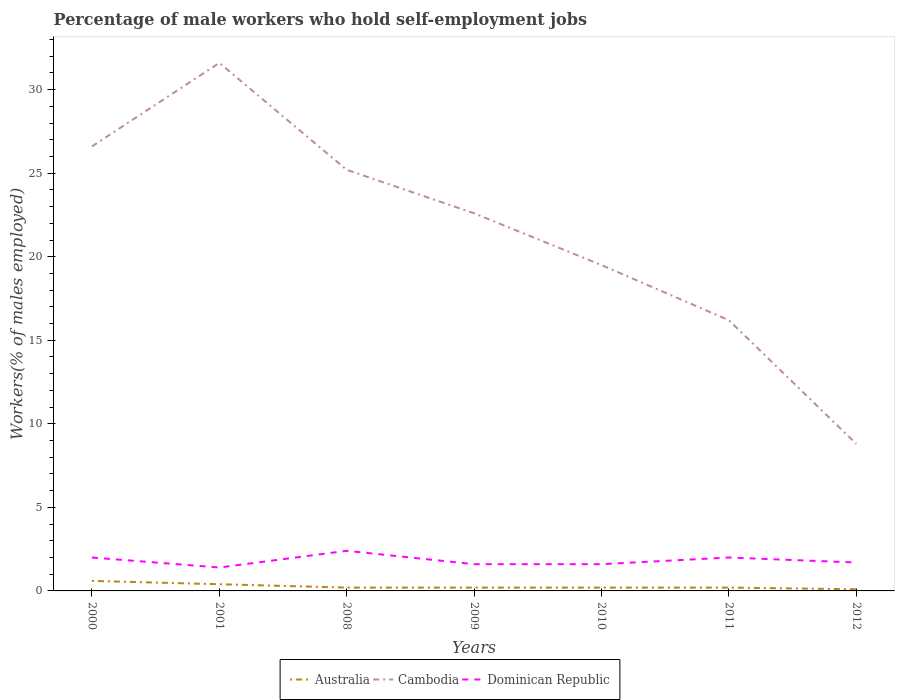Is the number of lines equal to the number of legend labels?
Keep it short and to the point. Yes. Across all years, what is the maximum percentage of self-employed male workers in Australia?
Ensure brevity in your answer.  0.1. What is the total percentage of self-employed male workers in Australia in the graph?
Keep it short and to the point. 0.1. What is the difference between the highest and the second highest percentage of self-employed male workers in Dominican Republic?
Make the answer very short. 1. What is the difference between the highest and the lowest percentage of self-employed male workers in Dominican Republic?
Provide a succinct answer. 3. How many lines are there?
Keep it short and to the point. 3. What is the difference between two consecutive major ticks on the Y-axis?
Your answer should be very brief. 5. Does the graph contain any zero values?
Offer a very short reply. No. What is the title of the graph?
Provide a succinct answer. Percentage of male workers who hold self-employment jobs. Does "Isle of Man" appear as one of the legend labels in the graph?
Your response must be concise. No. What is the label or title of the X-axis?
Provide a succinct answer. Years. What is the label or title of the Y-axis?
Make the answer very short. Workers(% of males employed). What is the Workers(% of males employed) in Australia in 2000?
Make the answer very short. 0.6. What is the Workers(% of males employed) in Cambodia in 2000?
Your answer should be compact. 26.6. What is the Workers(% of males employed) in Dominican Republic in 2000?
Keep it short and to the point. 2. What is the Workers(% of males employed) of Australia in 2001?
Your answer should be very brief. 0.4. What is the Workers(% of males employed) in Cambodia in 2001?
Offer a terse response. 31.6. What is the Workers(% of males employed) in Dominican Republic in 2001?
Offer a very short reply. 1.4. What is the Workers(% of males employed) in Australia in 2008?
Provide a succinct answer. 0.2. What is the Workers(% of males employed) in Cambodia in 2008?
Give a very brief answer. 25.2. What is the Workers(% of males employed) in Dominican Republic in 2008?
Offer a very short reply. 2.4. What is the Workers(% of males employed) of Australia in 2009?
Provide a succinct answer. 0.2. What is the Workers(% of males employed) in Cambodia in 2009?
Keep it short and to the point. 22.6. What is the Workers(% of males employed) of Dominican Republic in 2009?
Ensure brevity in your answer.  1.6. What is the Workers(% of males employed) of Australia in 2010?
Ensure brevity in your answer.  0.2. What is the Workers(% of males employed) of Cambodia in 2010?
Offer a terse response. 19.5. What is the Workers(% of males employed) in Dominican Republic in 2010?
Your answer should be very brief. 1.6. What is the Workers(% of males employed) of Australia in 2011?
Offer a terse response. 0.2. What is the Workers(% of males employed) in Cambodia in 2011?
Your response must be concise. 16.2. What is the Workers(% of males employed) of Australia in 2012?
Keep it short and to the point. 0.1. What is the Workers(% of males employed) in Cambodia in 2012?
Your response must be concise. 8.8. What is the Workers(% of males employed) of Dominican Republic in 2012?
Provide a succinct answer. 1.7. Across all years, what is the maximum Workers(% of males employed) of Australia?
Keep it short and to the point. 0.6. Across all years, what is the maximum Workers(% of males employed) of Cambodia?
Your answer should be compact. 31.6. Across all years, what is the maximum Workers(% of males employed) of Dominican Republic?
Provide a short and direct response. 2.4. Across all years, what is the minimum Workers(% of males employed) of Australia?
Make the answer very short. 0.1. Across all years, what is the minimum Workers(% of males employed) in Cambodia?
Your response must be concise. 8.8. Across all years, what is the minimum Workers(% of males employed) of Dominican Republic?
Provide a short and direct response. 1.4. What is the total Workers(% of males employed) in Cambodia in the graph?
Give a very brief answer. 150.5. What is the difference between the Workers(% of males employed) of Australia in 2000 and that in 2001?
Keep it short and to the point. 0.2. What is the difference between the Workers(% of males employed) in Cambodia in 2000 and that in 2001?
Provide a short and direct response. -5. What is the difference between the Workers(% of males employed) of Dominican Republic in 2000 and that in 2001?
Your response must be concise. 0.6. What is the difference between the Workers(% of males employed) of Cambodia in 2000 and that in 2009?
Offer a very short reply. 4. What is the difference between the Workers(% of males employed) in Australia in 2000 and that in 2011?
Keep it short and to the point. 0.4. What is the difference between the Workers(% of males employed) of Cambodia in 2000 and that in 2011?
Provide a succinct answer. 10.4. What is the difference between the Workers(% of males employed) of Australia in 2000 and that in 2012?
Your answer should be very brief. 0.5. What is the difference between the Workers(% of males employed) of Dominican Republic in 2000 and that in 2012?
Offer a terse response. 0.3. What is the difference between the Workers(% of males employed) of Australia in 2001 and that in 2008?
Offer a very short reply. 0.2. What is the difference between the Workers(% of males employed) in Dominican Republic in 2001 and that in 2008?
Give a very brief answer. -1. What is the difference between the Workers(% of males employed) of Australia in 2001 and that in 2009?
Provide a succinct answer. 0.2. What is the difference between the Workers(% of males employed) of Australia in 2001 and that in 2010?
Give a very brief answer. 0.2. What is the difference between the Workers(% of males employed) in Dominican Republic in 2001 and that in 2010?
Give a very brief answer. -0.2. What is the difference between the Workers(% of males employed) in Australia in 2001 and that in 2011?
Your answer should be very brief. 0.2. What is the difference between the Workers(% of males employed) of Cambodia in 2001 and that in 2011?
Your response must be concise. 15.4. What is the difference between the Workers(% of males employed) in Dominican Republic in 2001 and that in 2011?
Your response must be concise. -0.6. What is the difference between the Workers(% of males employed) of Cambodia in 2001 and that in 2012?
Offer a very short reply. 22.8. What is the difference between the Workers(% of males employed) of Cambodia in 2008 and that in 2009?
Keep it short and to the point. 2.6. What is the difference between the Workers(% of males employed) of Dominican Republic in 2008 and that in 2009?
Give a very brief answer. 0.8. What is the difference between the Workers(% of males employed) of Cambodia in 2008 and that in 2010?
Ensure brevity in your answer.  5.7. What is the difference between the Workers(% of males employed) in Dominican Republic in 2008 and that in 2010?
Your response must be concise. 0.8. What is the difference between the Workers(% of males employed) in Australia in 2008 and that in 2011?
Your answer should be very brief. 0. What is the difference between the Workers(% of males employed) in Dominican Republic in 2008 and that in 2011?
Offer a very short reply. 0.4. What is the difference between the Workers(% of males employed) of Dominican Republic in 2008 and that in 2012?
Provide a short and direct response. 0.7. What is the difference between the Workers(% of males employed) of Cambodia in 2009 and that in 2010?
Your answer should be compact. 3.1. What is the difference between the Workers(% of males employed) in Dominican Republic in 2009 and that in 2011?
Offer a very short reply. -0.4. What is the difference between the Workers(% of males employed) in Australia in 2009 and that in 2012?
Ensure brevity in your answer.  0.1. What is the difference between the Workers(% of males employed) in Cambodia in 2009 and that in 2012?
Provide a succinct answer. 13.8. What is the difference between the Workers(% of males employed) in Dominican Republic in 2009 and that in 2012?
Your answer should be compact. -0.1. What is the difference between the Workers(% of males employed) in Australia in 2010 and that in 2011?
Give a very brief answer. 0. What is the difference between the Workers(% of males employed) in Cambodia in 2010 and that in 2011?
Ensure brevity in your answer.  3.3. What is the difference between the Workers(% of males employed) of Dominican Republic in 2010 and that in 2011?
Offer a very short reply. -0.4. What is the difference between the Workers(% of males employed) in Cambodia in 2011 and that in 2012?
Ensure brevity in your answer.  7.4. What is the difference between the Workers(% of males employed) in Australia in 2000 and the Workers(% of males employed) in Cambodia in 2001?
Your response must be concise. -31. What is the difference between the Workers(% of males employed) in Cambodia in 2000 and the Workers(% of males employed) in Dominican Republic in 2001?
Offer a terse response. 25.2. What is the difference between the Workers(% of males employed) in Australia in 2000 and the Workers(% of males employed) in Cambodia in 2008?
Offer a terse response. -24.6. What is the difference between the Workers(% of males employed) of Australia in 2000 and the Workers(% of males employed) of Dominican Republic in 2008?
Give a very brief answer. -1.8. What is the difference between the Workers(% of males employed) of Cambodia in 2000 and the Workers(% of males employed) of Dominican Republic in 2008?
Ensure brevity in your answer.  24.2. What is the difference between the Workers(% of males employed) in Australia in 2000 and the Workers(% of males employed) in Cambodia in 2009?
Provide a short and direct response. -22. What is the difference between the Workers(% of males employed) in Australia in 2000 and the Workers(% of males employed) in Dominican Republic in 2009?
Ensure brevity in your answer.  -1. What is the difference between the Workers(% of males employed) in Australia in 2000 and the Workers(% of males employed) in Cambodia in 2010?
Ensure brevity in your answer.  -18.9. What is the difference between the Workers(% of males employed) of Australia in 2000 and the Workers(% of males employed) of Dominican Republic in 2010?
Your answer should be compact. -1. What is the difference between the Workers(% of males employed) of Australia in 2000 and the Workers(% of males employed) of Cambodia in 2011?
Make the answer very short. -15.6. What is the difference between the Workers(% of males employed) in Australia in 2000 and the Workers(% of males employed) in Dominican Republic in 2011?
Your answer should be very brief. -1.4. What is the difference between the Workers(% of males employed) of Cambodia in 2000 and the Workers(% of males employed) of Dominican Republic in 2011?
Give a very brief answer. 24.6. What is the difference between the Workers(% of males employed) of Cambodia in 2000 and the Workers(% of males employed) of Dominican Republic in 2012?
Ensure brevity in your answer.  24.9. What is the difference between the Workers(% of males employed) in Australia in 2001 and the Workers(% of males employed) in Cambodia in 2008?
Your answer should be compact. -24.8. What is the difference between the Workers(% of males employed) of Cambodia in 2001 and the Workers(% of males employed) of Dominican Republic in 2008?
Your answer should be compact. 29.2. What is the difference between the Workers(% of males employed) of Australia in 2001 and the Workers(% of males employed) of Cambodia in 2009?
Offer a very short reply. -22.2. What is the difference between the Workers(% of males employed) of Australia in 2001 and the Workers(% of males employed) of Dominican Republic in 2009?
Keep it short and to the point. -1.2. What is the difference between the Workers(% of males employed) in Australia in 2001 and the Workers(% of males employed) in Cambodia in 2010?
Your response must be concise. -19.1. What is the difference between the Workers(% of males employed) of Australia in 2001 and the Workers(% of males employed) of Cambodia in 2011?
Keep it short and to the point. -15.8. What is the difference between the Workers(% of males employed) of Cambodia in 2001 and the Workers(% of males employed) of Dominican Republic in 2011?
Provide a succinct answer. 29.6. What is the difference between the Workers(% of males employed) of Australia in 2001 and the Workers(% of males employed) of Dominican Republic in 2012?
Your response must be concise. -1.3. What is the difference between the Workers(% of males employed) in Cambodia in 2001 and the Workers(% of males employed) in Dominican Republic in 2012?
Your answer should be very brief. 29.9. What is the difference between the Workers(% of males employed) of Australia in 2008 and the Workers(% of males employed) of Cambodia in 2009?
Keep it short and to the point. -22.4. What is the difference between the Workers(% of males employed) of Cambodia in 2008 and the Workers(% of males employed) of Dominican Republic in 2009?
Give a very brief answer. 23.6. What is the difference between the Workers(% of males employed) in Australia in 2008 and the Workers(% of males employed) in Cambodia in 2010?
Offer a terse response. -19.3. What is the difference between the Workers(% of males employed) in Cambodia in 2008 and the Workers(% of males employed) in Dominican Republic in 2010?
Your answer should be very brief. 23.6. What is the difference between the Workers(% of males employed) in Australia in 2008 and the Workers(% of males employed) in Cambodia in 2011?
Your answer should be compact. -16. What is the difference between the Workers(% of males employed) in Cambodia in 2008 and the Workers(% of males employed) in Dominican Republic in 2011?
Ensure brevity in your answer.  23.2. What is the difference between the Workers(% of males employed) of Cambodia in 2008 and the Workers(% of males employed) of Dominican Republic in 2012?
Offer a very short reply. 23.5. What is the difference between the Workers(% of males employed) of Australia in 2009 and the Workers(% of males employed) of Cambodia in 2010?
Offer a terse response. -19.3. What is the difference between the Workers(% of males employed) in Australia in 2009 and the Workers(% of males employed) in Dominican Republic in 2010?
Your answer should be very brief. -1.4. What is the difference between the Workers(% of males employed) of Cambodia in 2009 and the Workers(% of males employed) of Dominican Republic in 2010?
Offer a very short reply. 21. What is the difference between the Workers(% of males employed) of Australia in 2009 and the Workers(% of males employed) of Cambodia in 2011?
Keep it short and to the point. -16. What is the difference between the Workers(% of males employed) of Cambodia in 2009 and the Workers(% of males employed) of Dominican Republic in 2011?
Your response must be concise. 20.6. What is the difference between the Workers(% of males employed) of Cambodia in 2009 and the Workers(% of males employed) of Dominican Republic in 2012?
Offer a very short reply. 20.9. What is the difference between the Workers(% of males employed) of Australia in 2010 and the Workers(% of males employed) of Dominican Republic in 2011?
Provide a succinct answer. -1.8. What is the difference between the Workers(% of males employed) of Australia in 2010 and the Workers(% of males employed) of Cambodia in 2012?
Provide a succinct answer. -8.6. What is the difference between the Workers(% of males employed) in Australia in 2010 and the Workers(% of males employed) in Dominican Republic in 2012?
Make the answer very short. -1.5. What is the difference between the Workers(% of males employed) in Cambodia in 2010 and the Workers(% of males employed) in Dominican Republic in 2012?
Make the answer very short. 17.8. What is the difference between the Workers(% of males employed) of Australia in 2011 and the Workers(% of males employed) of Dominican Republic in 2012?
Offer a very short reply. -1.5. What is the average Workers(% of males employed) in Australia per year?
Ensure brevity in your answer.  0.27. What is the average Workers(% of males employed) in Dominican Republic per year?
Make the answer very short. 1.81. In the year 2000, what is the difference between the Workers(% of males employed) in Australia and Workers(% of males employed) in Dominican Republic?
Your answer should be compact. -1.4. In the year 2000, what is the difference between the Workers(% of males employed) of Cambodia and Workers(% of males employed) of Dominican Republic?
Your response must be concise. 24.6. In the year 2001, what is the difference between the Workers(% of males employed) in Australia and Workers(% of males employed) in Cambodia?
Your answer should be very brief. -31.2. In the year 2001, what is the difference between the Workers(% of males employed) of Australia and Workers(% of males employed) of Dominican Republic?
Give a very brief answer. -1. In the year 2001, what is the difference between the Workers(% of males employed) of Cambodia and Workers(% of males employed) of Dominican Republic?
Your answer should be very brief. 30.2. In the year 2008, what is the difference between the Workers(% of males employed) in Australia and Workers(% of males employed) in Dominican Republic?
Your response must be concise. -2.2. In the year 2008, what is the difference between the Workers(% of males employed) of Cambodia and Workers(% of males employed) of Dominican Republic?
Your response must be concise. 22.8. In the year 2009, what is the difference between the Workers(% of males employed) in Australia and Workers(% of males employed) in Cambodia?
Provide a short and direct response. -22.4. In the year 2010, what is the difference between the Workers(% of males employed) in Australia and Workers(% of males employed) in Cambodia?
Your answer should be very brief. -19.3. In the year 2010, what is the difference between the Workers(% of males employed) in Australia and Workers(% of males employed) in Dominican Republic?
Your response must be concise. -1.4. In the year 2011, what is the difference between the Workers(% of males employed) in Cambodia and Workers(% of males employed) in Dominican Republic?
Provide a short and direct response. 14.2. In the year 2012, what is the difference between the Workers(% of males employed) in Cambodia and Workers(% of males employed) in Dominican Republic?
Ensure brevity in your answer.  7.1. What is the ratio of the Workers(% of males employed) of Cambodia in 2000 to that in 2001?
Your response must be concise. 0.84. What is the ratio of the Workers(% of males employed) in Dominican Republic in 2000 to that in 2001?
Provide a short and direct response. 1.43. What is the ratio of the Workers(% of males employed) in Cambodia in 2000 to that in 2008?
Ensure brevity in your answer.  1.06. What is the ratio of the Workers(% of males employed) of Cambodia in 2000 to that in 2009?
Keep it short and to the point. 1.18. What is the ratio of the Workers(% of males employed) in Dominican Republic in 2000 to that in 2009?
Offer a very short reply. 1.25. What is the ratio of the Workers(% of males employed) of Cambodia in 2000 to that in 2010?
Keep it short and to the point. 1.36. What is the ratio of the Workers(% of males employed) in Dominican Republic in 2000 to that in 2010?
Provide a succinct answer. 1.25. What is the ratio of the Workers(% of males employed) in Australia in 2000 to that in 2011?
Ensure brevity in your answer.  3. What is the ratio of the Workers(% of males employed) in Cambodia in 2000 to that in 2011?
Ensure brevity in your answer.  1.64. What is the ratio of the Workers(% of males employed) in Cambodia in 2000 to that in 2012?
Keep it short and to the point. 3.02. What is the ratio of the Workers(% of males employed) of Dominican Republic in 2000 to that in 2012?
Make the answer very short. 1.18. What is the ratio of the Workers(% of males employed) in Cambodia in 2001 to that in 2008?
Your response must be concise. 1.25. What is the ratio of the Workers(% of males employed) of Dominican Republic in 2001 to that in 2008?
Ensure brevity in your answer.  0.58. What is the ratio of the Workers(% of males employed) in Cambodia in 2001 to that in 2009?
Your answer should be compact. 1.4. What is the ratio of the Workers(% of males employed) of Australia in 2001 to that in 2010?
Ensure brevity in your answer.  2. What is the ratio of the Workers(% of males employed) in Cambodia in 2001 to that in 2010?
Keep it short and to the point. 1.62. What is the ratio of the Workers(% of males employed) of Dominican Republic in 2001 to that in 2010?
Provide a short and direct response. 0.88. What is the ratio of the Workers(% of males employed) of Cambodia in 2001 to that in 2011?
Provide a succinct answer. 1.95. What is the ratio of the Workers(% of males employed) in Australia in 2001 to that in 2012?
Provide a succinct answer. 4. What is the ratio of the Workers(% of males employed) in Cambodia in 2001 to that in 2012?
Ensure brevity in your answer.  3.59. What is the ratio of the Workers(% of males employed) in Dominican Republic in 2001 to that in 2012?
Provide a short and direct response. 0.82. What is the ratio of the Workers(% of males employed) of Australia in 2008 to that in 2009?
Your answer should be compact. 1. What is the ratio of the Workers(% of males employed) of Cambodia in 2008 to that in 2009?
Make the answer very short. 1.11. What is the ratio of the Workers(% of males employed) of Australia in 2008 to that in 2010?
Offer a terse response. 1. What is the ratio of the Workers(% of males employed) in Cambodia in 2008 to that in 2010?
Your answer should be very brief. 1.29. What is the ratio of the Workers(% of males employed) of Dominican Republic in 2008 to that in 2010?
Provide a succinct answer. 1.5. What is the ratio of the Workers(% of males employed) of Cambodia in 2008 to that in 2011?
Provide a short and direct response. 1.56. What is the ratio of the Workers(% of males employed) in Dominican Republic in 2008 to that in 2011?
Offer a very short reply. 1.2. What is the ratio of the Workers(% of males employed) in Australia in 2008 to that in 2012?
Provide a short and direct response. 2. What is the ratio of the Workers(% of males employed) of Cambodia in 2008 to that in 2012?
Give a very brief answer. 2.86. What is the ratio of the Workers(% of males employed) in Dominican Republic in 2008 to that in 2012?
Provide a succinct answer. 1.41. What is the ratio of the Workers(% of males employed) of Australia in 2009 to that in 2010?
Your answer should be very brief. 1. What is the ratio of the Workers(% of males employed) in Cambodia in 2009 to that in 2010?
Give a very brief answer. 1.16. What is the ratio of the Workers(% of males employed) of Dominican Republic in 2009 to that in 2010?
Your response must be concise. 1. What is the ratio of the Workers(% of males employed) of Australia in 2009 to that in 2011?
Your answer should be very brief. 1. What is the ratio of the Workers(% of males employed) of Cambodia in 2009 to that in 2011?
Ensure brevity in your answer.  1.4. What is the ratio of the Workers(% of males employed) of Dominican Republic in 2009 to that in 2011?
Your response must be concise. 0.8. What is the ratio of the Workers(% of males employed) in Cambodia in 2009 to that in 2012?
Your response must be concise. 2.57. What is the ratio of the Workers(% of males employed) of Dominican Republic in 2009 to that in 2012?
Offer a terse response. 0.94. What is the ratio of the Workers(% of males employed) of Australia in 2010 to that in 2011?
Offer a very short reply. 1. What is the ratio of the Workers(% of males employed) of Cambodia in 2010 to that in 2011?
Make the answer very short. 1.2. What is the ratio of the Workers(% of males employed) in Dominican Republic in 2010 to that in 2011?
Your answer should be very brief. 0.8. What is the ratio of the Workers(% of males employed) in Cambodia in 2010 to that in 2012?
Your response must be concise. 2.22. What is the ratio of the Workers(% of males employed) in Australia in 2011 to that in 2012?
Offer a very short reply. 2. What is the ratio of the Workers(% of males employed) of Cambodia in 2011 to that in 2012?
Offer a very short reply. 1.84. What is the ratio of the Workers(% of males employed) in Dominican Republic in 2011 to that in 2012?
Provide a succinct answer. 1.18. What is the difference between the highest and the second highest Workers(% of males employed) of Australia?
Your answer should be very brief. 0.2. What is the difference between the highest and the second highest Workers(% of males employed) in Cambodia?
Offer a terse response. 5. What is the difference between the highest and the second highest Workers(% of males employed) of Dominican Republic?
Offer a very short reply. 0.4. What is the difference between the highest and the lowest Workers(% of males employed) of Australia?
Make the answer very short. 0.5. What is the difference between the highest and the lowest Workers(% of males employed) in Cambodia?
Provide a short and direct response. 22.8. What is the difference between the highest and the lowest Workers(% of males employed) of Dominican Republic?
Offer a very short reply. 1. 